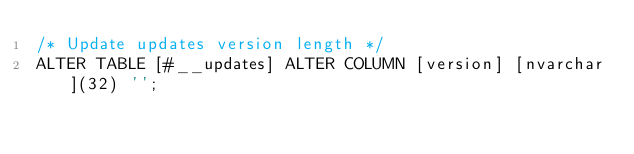<code> <loc_0><loc_0><loc_500><loc_500><_SQL_>/* Update updates version length */
ALTER TABLE [#__updates] ALTER COLUMN [version] [nvarchar](32) '';
</code> 